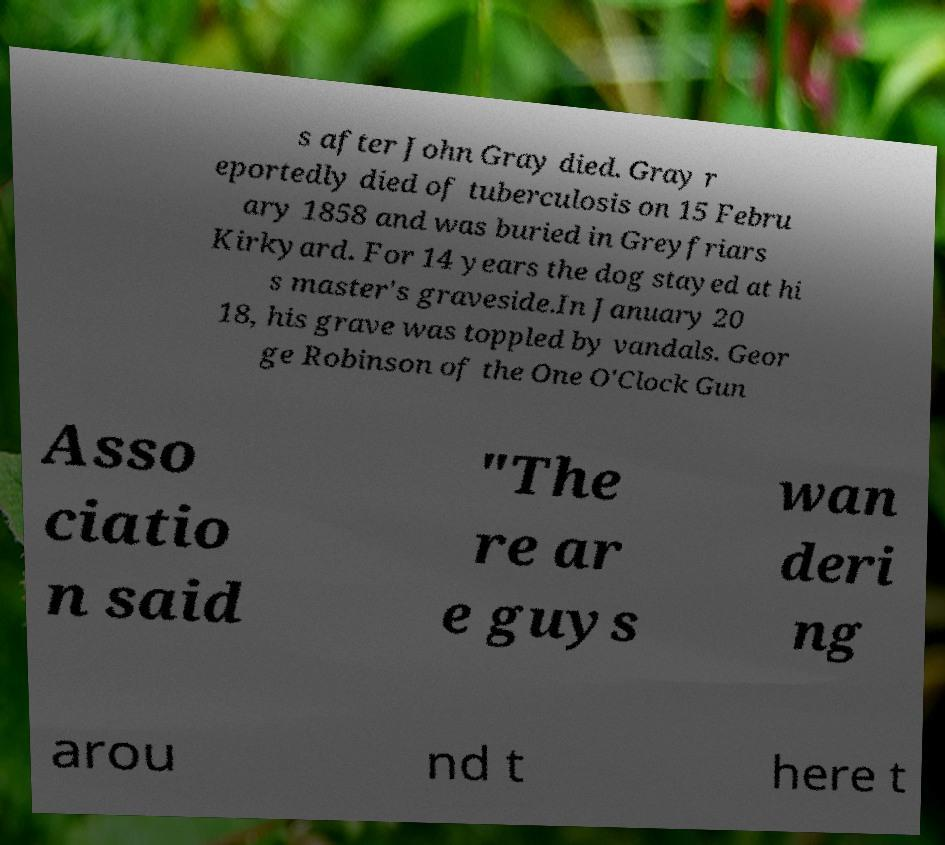I need the written content from this picture converted into text. Can you do that? s after John Gray died. Gray r eportedly died of tuberculosis on 15 Febru ary 1858 and was buried in Greyfriars Kirkyard. For 14 years the dog stayed at hi s master's graveside.In January 20 18, his grave was toppled by vandals. Geor ge Robinson of the One O'Clock Gun Asso ciatio n said "The re ar e guys wan deri ng arou nd t here t 